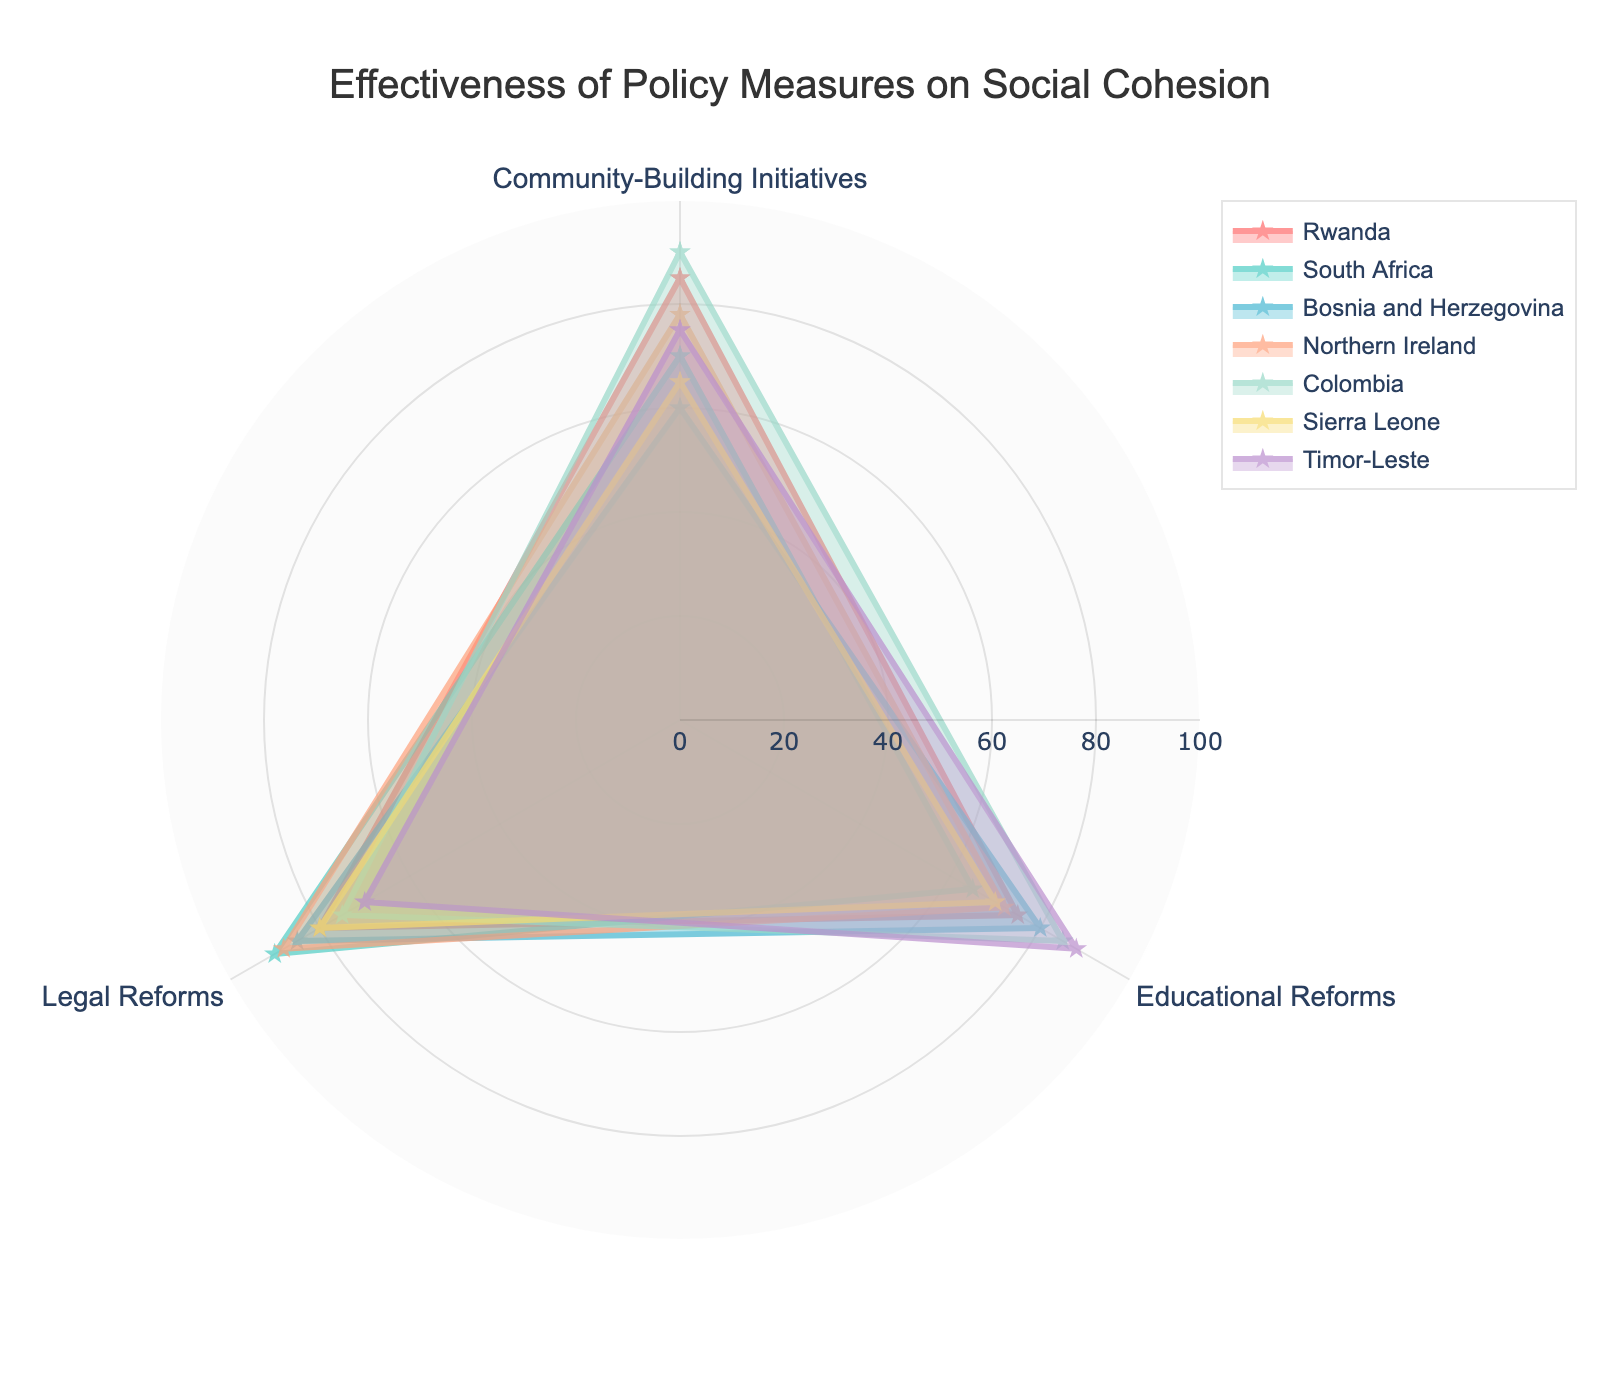What is the title of the figure? The title of the figure is located at the top and provides a summary of what the figure is about.
Answer: Effectiveness of Policy Measures on Social Cohesion What range is shown on the radial axis? The radial axis range can be identified by looking at the minimum and maximum values indicated on the figure. The range is from 0 to 100.
Answer: 0 to 100 Which country has the highest effectiveness in Community-Building Initiatives? To find this, locate the Community-Building Initiatives axis and determine which country's marker is furthest from the center.
Answer: Colombia Compare educational reforms in Bosnia and Herzegovina and Timor-Leste. Which country has a higher score? By tracing the data points along the Educational Reforms axis for both countries, we can compare their values. Bosnia and Herzegovina has a score of 80, while Timor-Leste has a score of 88.
Answer: Timor-Leste What is the average effectiveness of Legal Reforms across all countries? The average is found by summing the Legal Reforms values for all countries and dividing by the number of countries: (80+90+85+88+75+80+70)/7. Summing these gives 568, and dividing by 7 gives 81.14.
Answer: 81.14 Which country has the least effectiveness in Educational Reforms? Locate the Educational Reforms axis and identify the country with the lowest value. South Africa has the lowest score of 65.
Answer: South Africa How many policy measures are evaluated in the figure? By counting the number of different policy measures categories, we can find the answer. There are Community-Building Initiatives, Educational Reforms, and Legal Reforms, totaling to 3 policy measures.
Answer: 3 Which two countries have the closest scores in Community-Building Initiatives? By comparing the scores in Community-Building Initiatives for all countries, we see that Bosnia and Herzegovina (60) and Sierra Leone (65) have the closest scores with a difference of 5.
Answer: Bosnia and Herzegovina and Sierra Leone Based on the figure, which policy measure has the highest overall effectiveness when averaging across all countries? We calculate the average for each policy measure: (85+70+60+78+90+65+75)/7 for Community-Building Initiatives, (75+65+80+72+85+70+88)/7 for Educational Reforms, and (80+90+85+88+75+80+70)/7 for Legal Reforms. The calculations yield approximately 74.71, 76.43, and 81.14, respectively. Thus, Legal Reforms have the highest average effectiveness.
Answer: Legal Reforms What are the effectiveness values for Educational Reforms in Rwanda and South Africa? By referring to the Educational Reforms points for these countries on the figure, the values are 75 for Rwanda and 65 for South Africa.
Answer: 75 for Rwanda and 65 for South Africa 